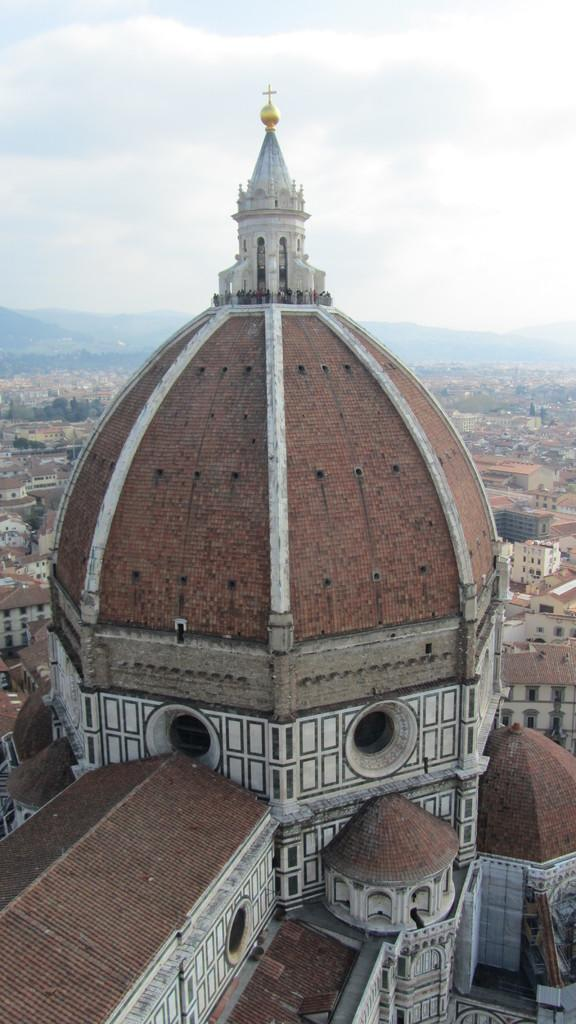What is the main subject in the front of the image? There is a building in the front of the image. What can be seen in the background of the image? There are buildings and mountains in the background of the image. What is visible at the top of the image? The sky is visible at the top of the image. What type of punishment is being handed out to the lumber in the image? There is no lumber or punishment present in the image. 